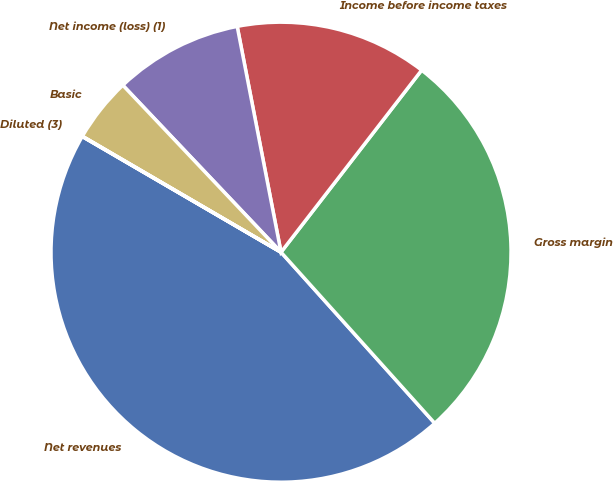Convert chart to OTSL. <chart><loc_0><loc_0><loc_500><loc_500><pie_chart><fcel>Net revenues<fcel>Gross margin<fcel>Income before income taxes<fcel>Net income (loss) (1)<fcel>Basic<fcel>Diluted (3)<nl><fcel>45.04%<fcel>27.88%<fcel>13.52%<fcel>9.02%<fcel>4.52%<fcel>0.02%<nl></chart> 